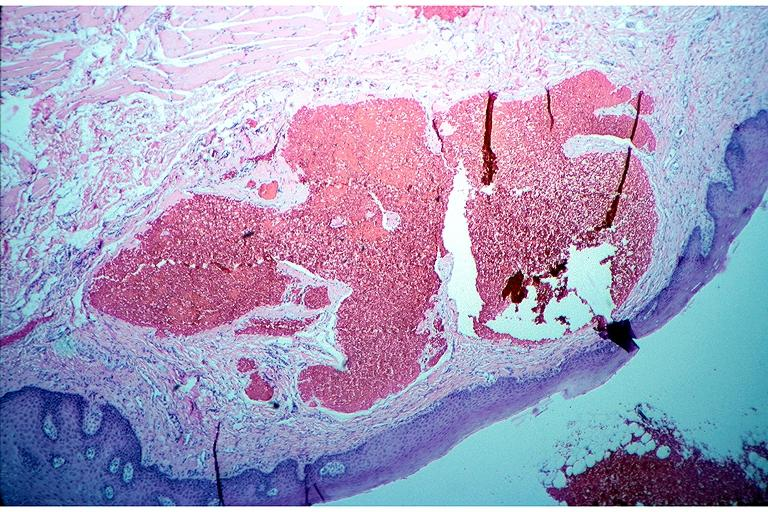does this image show cavernous hemangioma?
Answer the question using a single word or phrase. Yes 